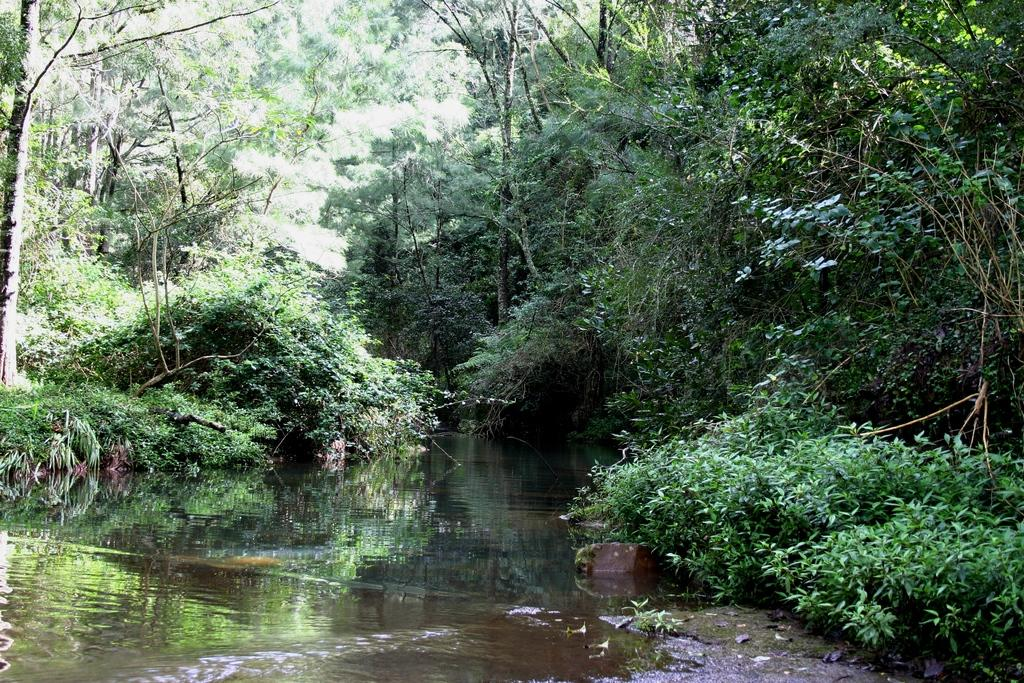What is the main feature of the image? The main feature of the image is a water surface. What can be seen surrounding the water surface? There are many trees and plants around the water surface. Can you tell me how the secretary is helping the stream in the image? There is no secretary or stream present in the image; it features a water surface surrounded by trees and plants. 